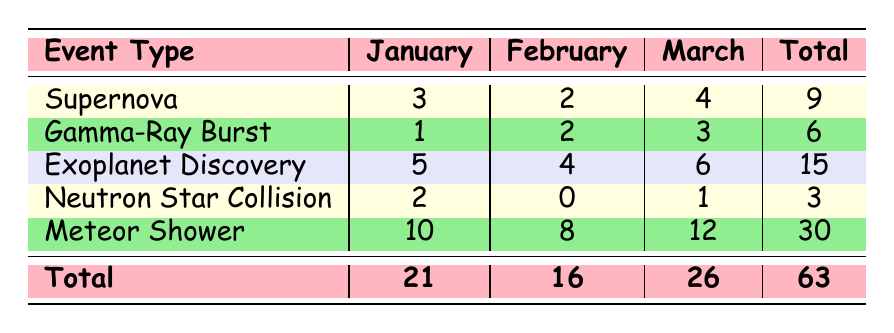What is the total number of Exoplanet Discovery events observed? The total number of Exoplanet Discovery events can be found in the "Total" column for that event type, which shows the sum of observations from January, February, and March. For Exoplanet Discovery, the total is 15.
Answer: 15 Which month had the highest number of Meteor Shower events? To determine the month with the highest number of Meteor Shower events, we look at the counts in each month's column. January had 10, February had 8, and March had 12. The highest count is in March, which is 12.
Answer: March How many more Supernova events were observed in March than in January? We need to compare the counts of Supernova events in March (4) and January (3). The difference can be calculated as 4 - 3 = 1. Therefore, there was 1 more Supernova event in March compared to January.
Answer: 1 Are there any months in which no Neutron Star Collision events were observed? Looking at the counts in the Neutron Star Collision row, February has a count of 0, indicating that no events were observed during that month.
Answer: Yes What is the average number of Gamma-Ray Burst events observed per month? We add up the counts for Gamma-Ray Burst events over the three months: 1 (January) + 2 (February) + 3 (March) = 6. To find the average, we divide the total by the number of months: 6 / 3 = 2.
Answer: 2 What percentage of the total events in March were Meteor Shower events? First, we need to find the total number of events in March. From the table, this is 26. Meteor Shower events in March were 12. To find the percentage, we calculate (12 / 26) * 100, which gives about 46.15%.
Answer: 46.15% How many events were observed in total over the three months? By looking at the "Total" row, we find the overall count was 63, which is the sum of all events observed across the three months.
Answer: 63 Which event had the least observations in February? We compare the counts of all events in February: Supernova (2), Gamma-Ray Burst (2), Exoplanet Discovery (4), Neutron Star Collision (0), and Meteor Shower (8). Neutron Star Collision has the least with a count of 0.
Answer: Neutron Star Collision In which month did the most Gamma-Ray Bursts occur? We observe the counts of Gamma-Ray Bursts across the months: January has 1, February has 2, and March has 3. March has the highest count at 3 Gamma-Ray Bursts.
Answer: March 